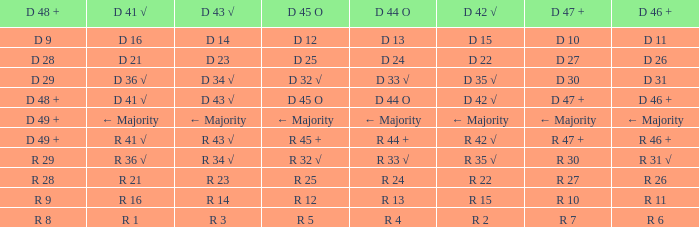What is the value of D 45 O when the value of D 44 O is ← majority? ← Majority. 